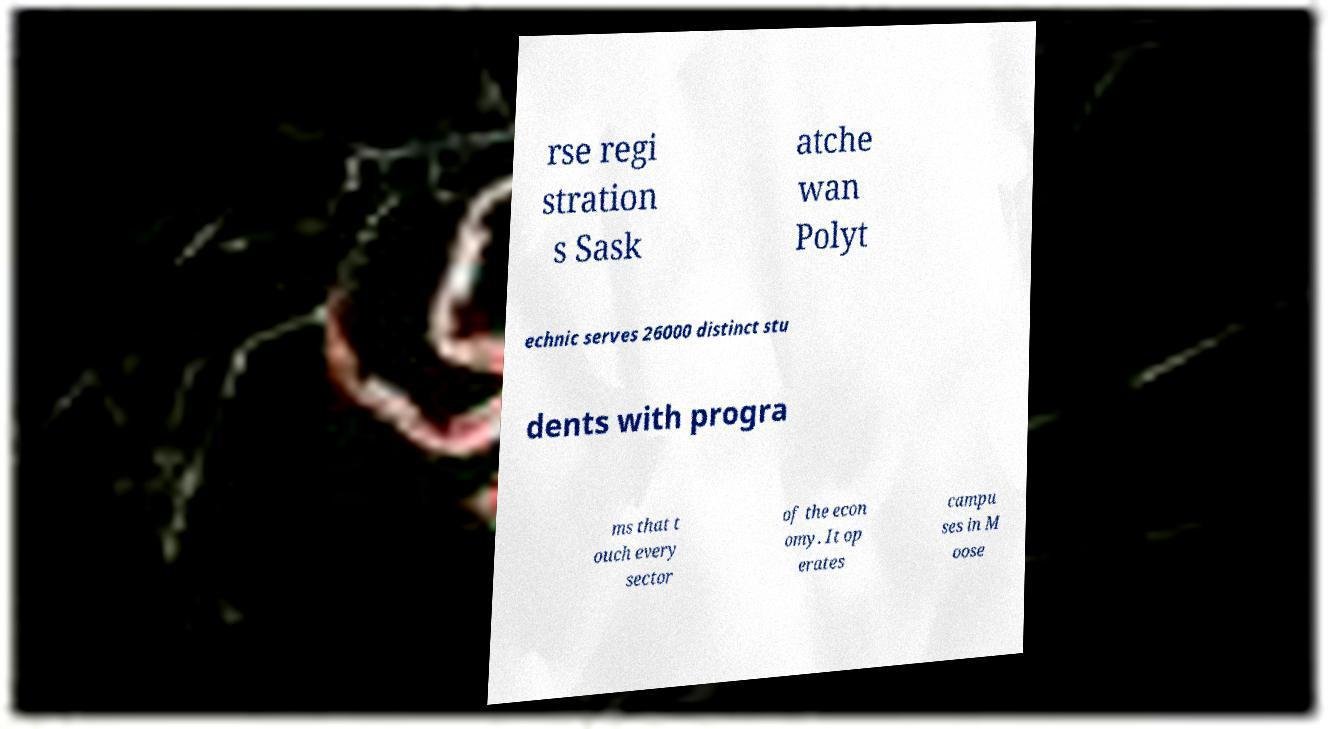Could you extract and type out the text from this image? rse regi stration s Sask atche wan Polyt echnic serves 26000 distinct stu dents with progra ms that t ouch every sector of the econ omy. It op erates campu ses in M oose 